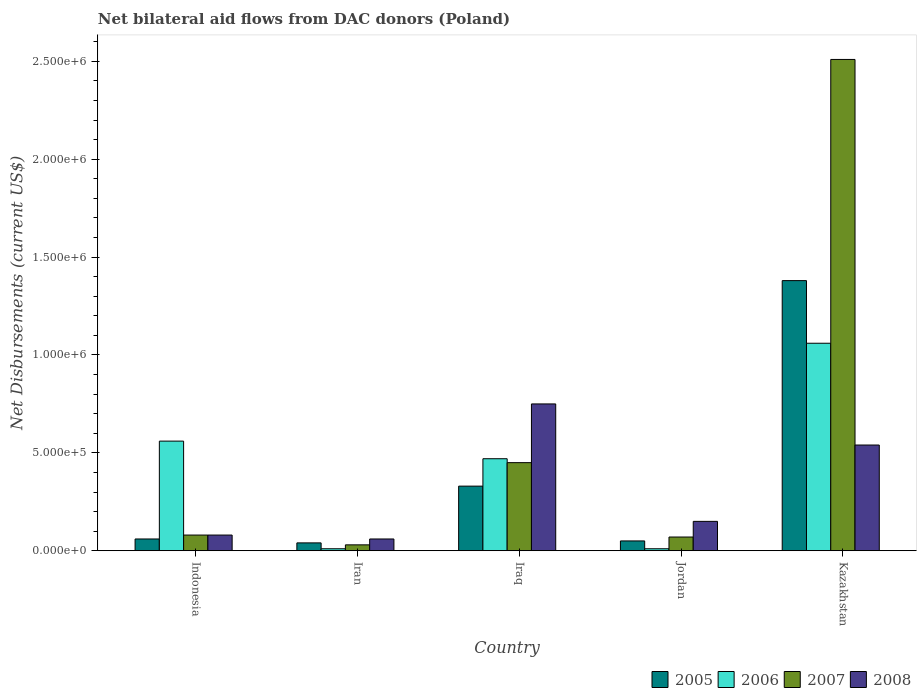Are the number of bars on each tick of the X-axis equal?
Your answer should be compact. Yes. What is the label of the 5th group of bars from the left?
Ensure brevity in your answer.  Kazakhstan. What is the net bilateral aid flows in 2008 in Iraq?
Keep it short and to the point. 7.50e+05. Across all countries, what is the maximum net bilateral aid flows in 2008?
Your answer should be very brief. 7.50e+05. In which country was the net bilateral aid flows in 2006 maximum?
Provide a short and direct response. Kazakhstan. In which country was the net bilateral aid flows in 2007 minimum?
Offer a terse response. Iran. What is the total net bilateral aid flows in 2006 in the graph?
Offer a terse response. 2.11e+06. What is the difference between the net bilateral aid flows in 2008 in Jordan and that in Kazakhstan?
Give a very brief answer. -3.90e+05. What is the difference between the net bilateral aid flows in 2007 in Kazakhstan and the net bilateral aid flows in 2006 in Jordan?
Make the answer very short. 2.50e+06. What is the average net bilateral aid flows in 2006 per country?
Make the answer very short. 4.22e+05. What is the difference between the net bilateral aid flows of/in 2006 and net bilateral aid flows of/in 2008 in Iran?
Offer a very short reply. -5.00e+04. In how many countries, is the net bilateral aid flows in 2008 greater than 200000 US$?
Provide a short and direct response. 2. What is the ratio of the net bilateral aid flows in 2006 in Iraq to that in Kazakhstan?
Your answer should be compact. 0.44. What is the difference between the highest and the second highest net bilateral aid flows in 2007?
Your answer should be very brief. 2.43e+06. What is the difference between the highest and the lowest net bilateral aid flows in 2006?
Provide a succinct answer. 1.05e+06. In how many countries, is the net bilateral aid flows in 2005 greater than the average net bilateral aid flows in 2005 taken over all countries?
Your answer should be compact. 1. Is the sum of the net bilateral aid flows in 2007 in Iraq and Kazakhstan greater than the maximum net bilateral aid flows in 2008 across all countries?
Provide a succinct answer. Yes. Is it the case that in every country, the sum of the net bilateral aid flows in 2005 and net bilateral aid flows in 2007 is greater than the sum of net bilateral aid flows in 2008 and net bilateral aid flows in 2006?
Offer a terse response. No. What does the 1st bar from the left in Jordan represents?
Offer a terse response. 2005. Is it the case that in every country, the sum of the net bilateral aid flows in 2007 and net bilateral aid flows in 2005 is greater than the net bilateral aid flows in 2006?
Make the answer very short. No. How many bars are there?
Offer a terse response. 20. How many legend labels are there?
Your answer should be compact. 4. How are the legend labels stacked?
Make the answer very short. Horizontal. What is the title of the graph?
Offer a terse response. Net bilateral aid flows from DAC donors (Poland). Does "1990" appear as one of the legend labels in the graph?
Your answer should be very brief. No. What is the label or title of the X-axis?
Give a very brief answer. Country. What is the label or title of the Y-axis?
Give a very brief answer. Net Disbursements (current US$). What is the Net Disbursements (current US$) in 2006 in Indonesia?
Offer a terse response. 5.60e+05. What is the Net Disbursements (current US$) of 2006 in Iran?
Give a very brief answer. 10000. What is the Net Disbursements (current US$) in 2005 in Iraq?
Ensure brevity in your answer.  3.30e+05. What is the Net Disbursements (current US$) of 2006 in Iraq?
Provide a succinct answer. 4.70e+05. What is the Net Disbursements (current US$) of 2008 in Iraq?
Make the answer very short. 7.50e+05. What is the Net Disbursements (current US$) in 2005 in Jordan?
Provide a short and direct response. 5.00e+04. What is the Net Disbursements (current US$) of 2008 in Jordan?
Make the answer very short. 1.50e+05. What is the Net Disbursements (current US$) in 2005 in Kazakhstan?
Your answer should be compact. 1.38e+06. What is the Net Disbursements (current US$) of 2006 in Kazakhstan?
Ensure brevity in your answer.  1.06e+06. What is the Net Disbursements (current US$) of 2007 in Kazakhstan?
Give a very brief answer. 2.51e+06. What is the Net Disbursements (current US$) in 2008 in Kazakhstan?
Make the answer very short. 5.40e+05. Across all countries, what is the maximum Net Disbursements (current US$) of 2005?
Ensure brevity in your answer.  1.38e+06. Across all countries, what is the maximum Net Disbursements (current US$) in 2006?
Make the answer very short. 1.06e+06. Across all countries, what is the maximum Net Disbursements (current US$) of 2007?
Your answer should be very brief. 2.51e+06. Across all countries, what is the maximum Net Disbursements (current US$) of 2008?
Give a very brief answer. 7.50e+05. Across all countries, what is the minimum Net Disbursements (current US$) in 2007?
Provide a succinct answer. 3.00e+04. What is the total Net Disbursements (current US$) of 2005 in the graph?
Your response must be concise. 1.86e+06. What is the total Net Disbursements (current US$) in 2006 in the graph?
Ensure brevity in your answer.  2.11e+06. What is the total Net Disbursements (current US$) in 2007 in the graph?
Ensure brevity in your answer.  3.14e+06. What is the total Net Disbursements (current US$) of 2008 in the graph?
Provide a succinct answer. 1.58e+06. What is the difference between the Net Disbursements (current US$) in 2007 in Indonesia and that in Iran?
Offer a very short reply. 5.00e+04. What is the difference between the Net Disbursements (current US$) of 2008 in Indonesia and that in Iran?
Make the answer very short. 2.00e+04. What is the difference between the Net Disbursements (current US$) in 2007 in Indonesia and that in Iraq?
Give a very brief answer. -3.70e+05. What is the difference between the Net Disbursements (current US$) in 2008 in Indonesia and that in Iraq?
Keep it short and to the point. -6.70e+05. What is the difference between the Net Disbursements (current US$) of 2005 in Indonesia and that in Jordan?
Make the answer very short. 10000. What is the difference between the Net Disbursements (current US$) in 2008 in Indonesia and that in Jordan?
Offer a very short reply. -7.00e+04. What is the difference between the Net Disbursements (current US$) of 2005 in Indonesia and that in Kazakhstan?
Your answer should be compact. -1.32e+06. What is the difference between the Net Disbursements (current US$) of 2006 in Indonesia and that in Kazakhstan?
Keep it short and to the point. -5.00e+05. What is the difference between the Net Disbursements (current US$) in 2007 in Indonesia and that in Kazakhstan?
Give a very brief answer. -2.43e+06. What is the difference between the Net Disbursements (current US$) of 2008 in Indonesia and that in Kazakhstan?
Offer a very short reply. -4.60e+05. What is the difference between the Net Disbursements (current US$) of 2006 in Iran and that in Iraq?
Keep it short and to the point. -4.60e+05. What is the difference between the Net Disbursements (current US$) in 2007 in Iran and that in Iraq?
Your answer should be very brief. -4.20e+05. What is the difference between the Net Disbursements (current US$) in 2008 in Iran and that in Iraq?
Your answer should be compact. -6.90e+05. What is the difference between the Net Disbursements (current US$) in 2005 in Iran and that in Jordan?
Make the answer very short. -10000. What is the difference between the Net Disbursements (current US$) of 2005 in Iran and that in Kazakhstan?
Your response must be concise. -1.34e+06. What is the difference between the Net Disbursements (current US$) of 2006 in Iran and that in Kazakhstan?
Give a very brief answer. -1.05e+06. What is the difference between the Net Disbursements (current US$) in 2007 in Iran and that in Kazakhstan?
Provide a short and direct response. -2.48e+06. What is the difference between the Net Disbursements (current US$) in 2008 in Iran and that in Kazakhstan?
Give a very brief answer. -4.80e+05. What is the difference between the Net Disbursements (current US$) in 2005 in Iraq and that in Jordan?
Provide a succinct answer. 2.80e+05. What is the difference between the Net Disbursements (current US$) of 2008 in Iraq and that in Jordan?
Your answer should be very brief. 6.00e+05. What is the difference between the Net Disbursements (current US$) in 2005 in Iraq and that in Kazakhstan?
Offer a terse response. -1.05e+06. What is the difference between the Net Disbursements (current US$) of 2006 in Iraq and that in Kazakhstan?
Offer a terse response. -5.90e+05. What is the difference between the Net Disbursements (current US$) in 2007 in Iraq and that in Kazakhstan?
Your response must be concise. -2.06e+06. What is the difference between the Net Disbursements (current US$) of 2008 in Iraq and that in Kazakhstan?
Your answer should be very brief. 2.10e+05. What is the difference between the Net Disbursements (current US$) of 2005 in Jordan and that in Kazakhstan?
Offer a very short reply. -1.33e+06. What is the difference between the Net Disbursements (current US$) in 2006 in Jordan and that in Kazakhstan?
Keep it short and to the point. -1.05e+06. What is the difference between the Net Disbursements (current US$) of 2007 in Jordan and that in Kazakhstan?
Provide a short and direct response. -2.44e+06. What is the difference between the Net Disbursements (current US$) of 2008 in Jordan and that in Kazakhstan?
Your answer should be compact. -3.90e+05. What is the difference between the Net Disbursements (current US$) in 2005 in Indonesia and the Net Disbursements (current US$) in 2006 in Iran?
Your response must be concise. 5.00e+04. What is the difference between the Net Disbursements (current US$) in 2005 in Indonesia and the Net Disbursements (current US$) in 2008 in Iran?
Your response must be concise. 0. What is the difference between the Net Disbursements (current US$) of 2006 in Indonesia and the Net Disbursements (current US$) of 2007 in Iran?
Offer a very short reply. 5.30e+05. What is the difference between the Net Disbursements (current US$) of 2006 in Indonesia and the Net Disbursements (current US$) of 2008 in Iran?
Provide a succinct answer. 5.00e+05. What is the difference between the Net Disbursements (current US$) in 2005 in Indonesia and the Net Disbursements (current US$) in 2006 in Iraq?
Offer a very short reply. -4.10e+05. What is the difference between the Net Disbursements (current US$) in 2005 in Indonesia and the Net Disbursements (current US$) in 2007 in Iraq?
Provide a succinct answer. -3.90e+05. What is the difference between the Net Disbursements (current US$) of 2005 in Indonesia and the Net Disbursements (current US$) of 2008 in Iraq?
Offer a very short reply. -6.90e+05. What is the difference between the Net Disbursements (current US$) in 2007 in Indonesia and the Net Disbursements (current US$) in 2008 in Iraq?
Give a very brief answer. -6.70e+05. What is the difference between the Net Disbursements (current US$) in 2005 in Indonesia and the Net Disbursements (current US$) in 2007 in Jordan?
Provide a short and direct response. -10000. What is the difference between the Net Disbursements (current US$) in 2006 in Indonesia and the Net Disbursements (current US$) in 2008 in Jordan?
Offer a terse response. 4.10e+05. What is the difference between the Net Disbursements (current US$) of 2005 in Indonesia and the Net Disbursements (current US$) of 2006 in Kazakhstan?
Your response must be concise. -1.00e+06. What is the difference between the Net Disbursements (current US$) in 2005 in Indonesia and the Net Disbursements (current US$) in 2007 in Kazakhstan?
Your response must be concise. -2.45e+06. What is the difference between the Net Disbursements (current US$) in 2005 in Indonesia and the Net Disbursements (current US$) in 2008 in Kazakhstan?
Keep it short and to the point. -4.80e+05. What is the difference between the Net Disbursements (current US$) of 2006 in Indonesia and the Net Disbursements (current US$) of 2007 in Kazakhstan?
Offer a very short reply. -1.95e+06. What is the difference between the Net Disbursements (current US$) of 2007 in Indonesia and the Net Disbursements (current US$) of 2008 in Kazakhstan?
Provide a short and direct response. -4.60e+05. What is the difference between the Net Disbursements (current US$) of 2005 in Iran and the Net Disbursements (current US$) of 2006 in Iraq?
Keep it short and to the point. -4.30e+05. What is the difference between the Net Disbursements (current US$) of 2005 in Iran and the Net Disbursements (current US$) of 2007 in Iraq?
Give a very brief answer. -4.10e+05. What is the difference between the Net Disbursements (current US$) of 2005 in Iran and the Net Disbursements (current US$) of 2008 in Iraq?
Ensure brevity in your answer.  -7.10e+05. What is the difference between the Net Disbursements (current US$) in 2006 in Iran and the Net Disbursements (current US$) in 2007 in Iraq?
Your answer should be compact. -4.40e+05. What is the difference between the Net Disbursements (current US$) of 2006 in Iran and the Net Disbursements (current US$) of 2008 in Iraq?
Ensure brevity in your answer.  -7.40e+05. What is the difference between the Net Disbursements (current US$) of 2007 in Iran and the Net Disbursements (current US$) of 2008 in Iraq?
Your response must be concise. -7.20e+05. What is the difference between the Net Disbursements (current US$) of 2005 in Iran and the Net Disbursements (current US$) of 2006 in Jordan?
Provide a short and direct response. 3.00e+04. What is the difference between the Net Disbursements (current US$) in 2005 in Iran and the Net Disbursements (current US$) in 2007 in Jordan?
Provide a succinct answer. -3.00e+04. What is the difference between the Net Disbursements (current US$) of 2006 in Iran and the Net Disbursements (current US$) of 2008 in Jordan?
Your answer should be compact. -1.40e+05. What is the difference between the Net Disbursements (current US$) in 2005 in Iran and the Net Disbursements (current US$) in 2006 in Kazakhstan?
Keep it short and to the point. -1.02e+06. What is the difference between the Net Disbursements (current US$) in 2005 in Iran and the Net Disbursements (current US$) in 2007 in Kazakhstan?
Keep it short and to the point. -2.47e+06. What is the difference between the Net Disbursements (current US$) of 2005 in Iran and the Net Disbursements (current US$) of 2008 in Kazakhstan?
Offer a very short reply. -5.00e+05. What is the difference between the Net Disbursements (current US$) in 2006 in Iran and the Net Disbursements (current US$) in 2007 in Kazakhstan?
Provide a succinct answer. -2.50e+06. What is the difference between the Net Disbursements (current US$) of 2006 in Iran and the Net Disbursements (current US$) of 2008 in Kazakhstan?
Your response must be concise. -5.30e+05. What is the difference between the Net Disbursements (current US$) of 2007 in Iran and the Net Disbursements (current US$) of 2008 in Kazakhstan?
Your response must be concise. -5.10e+05. What is the difference between the Net Disbursements (current US$) of 2005 in Iraq and the Net Disbursements (current US$) of 2006 in Jordan?
Offer a very short reply. 3.20e+05. What is the difference between the Net Disbursements (current US$) of 2005 in Iraq and the Net Disbursements (current US$) of 2007 in Jordan?
Your answer should be compact. 2.60e+05. What is the difference between the Net Disbursements (current US$) in 2006 in Iraq and the Net Disbursements (current US$) in 2007 in Jordan?
Provide a short and direct response. 4.00e+05. What is the difference between the Net Disbursements (current US$) in 2006 in Iraq and the Net Disbursements (current US$) in 2008 in Jordan?
Ensure brevity in your answer.  3.20e+05. What is the difference between the Net Disbursements (current US$) of 2005 in Iraq and the Net Disbursements (current US$) of 2006 in Kazakhstan?
Your answer should be compact. -7.30e+05. What is the difference between the Net Disbursements (current US$) in 2005 in Iraq and the Net Disbursements (current US$) in 2007 in Kazakhstan?
Ensure brevity in your answer.  -2.18e+06. What is the difference between the Net Disbursements (current US$) in 2006 in Iraq and the Net Disbursements (current US$) in 2007 in Kazakhstan?
Offer a very short reply. -2.04e+06. What is the difference between the Net Disbursements (current US$) in 2007 in Iraq and the Net Disbursements (current US$) in 2008 in Kazakhstan?
Offer a terse response. -9.00e+04. What is the difference between the Net Disbursements (current US$) in 2005 in Jordan and the Net Disbursements (current US$) in 2006 in Kazakhstan?
Offer a terse response. -1.01e+06. What is the difference between the Net Disbursements (current US$) in 2005 in Jordan and the Net Disbursements (current US$) in 2007 in Kazakhstan?
Provide a short and direct response. -2.46e+06. What is the difference between the Net Disbursements (current US$) of 2005 in Jordan and the Net Disbursements (current US$) of 2008 in Kazakhstan?
Your answer should be very brief. -4.90e+05. What is the difference between the Net Disbursements (current US$) in 2006 in Jordan and the Net Disbursements (current US$) in 2007 in Kazakhstan?
Provide a short and direct response. -2.50e+06. What is the difference between the Net Disbursements (current US$) in 2006 in Jordan and the Net Disbursements (current US$) in 2008 in Kazakhstan?
Keep it short and to the point. -5.30e+05. What is the difference between the Net Disbursements (current US$) in 2007 in Jordan and the Net Disbursements (current US$) in 2008 in Kazakhstan?
Make the answer very short. -4.70e+05. What is the average Net Disbursements (current US$) in 2005 per country?
Provide a short and direct response. 3.72e+05. What is the average Net Disbursements (current US$) in 2006 per country?
Give a very brief answer. 4.22e+05. What is the average Net Disbursements (current US$) in 2007 per country?
Keep it short and to the point. 6.28e+05. What is the average Net Disbursements (current US$) in 2008 per country?
Ensure brevity in your answer.  3.16e+05. What is the difference between the Net Disbursements (current US$) in 2005 and Net Disbursements (current US$) in 2006 in Indonesia?
Your answer should be compact. -5.00e+05. What is the difference between the Net Disbursements (current US$) in 2006 and Net Disbursements (current US$) in 2007 in Indonesia?
Provide a short and direct response. 4.80e+05. What is the difference between the Net Disbursements (current US$) in 2006 and Net Disbursements (current US$) in 2008 in Indonesia?
Offer a terse response. 4.80e+05. What is the difference between the Net Disbursements (current US$) in 2005 and Net Disbursements (current US$) in 2006 in Iran?
Make the answer very short. 3.00e+04. What is the difference between the Net Disbursements (current US$) of 2005 and Net Disbursements (current US$) of 2008 in Iran?
Your answer should be very brief. -2.00e+04. What is the difference between the Net Disbursements (current US$) of 2006 and Net Disbursements (current US$) of 2007 in Iran?
Your response must be concise. -2.00e+04. What is the difference between the Net Disbursements (current US$) in 2006 and Net Disbursements (current US$) in 2008 in Iran?
Offer a very short reply. -5.00e+04. What is the difference between the Net Disbursements (current US$) of 2005 and Net Disbursements (current US$) of 2006 in Iraq?
Keep it short and to the point. -1.40e+05. What is the difference between the Net Disbursements (current US$) of 2005 and Net Disbursements (current US$) of 2008 in Iraq?
Provide a succinct answer. -4.20e+05. What is the difference between the Net Disbursements (current US$) in 2006 and Net Disbursements (current US$) in 2007 in Iraq?
Ensure brevity in your answer.  2.00e+04. What is the difference between the Net Disbursements (current US$) in 2006 and Net Disbursements (current US$) in 2008 in Iraq?
Your response must be concise. -2.80e+05. What is the difference between the Net Disbursements (current US$) in 2007 and Net Disbursements (current US$) in 2008 in Iraq?
Provide a succinct answer. -3.00e+05. What is the difference between the Net Disbursements (current US$) in 2005 and Net Disbursements (current US$) in 2006 in Jordan?
Provide a short and direct response. 4.00e+04. What is the difference between the Net Disbursements (current US$) of 2006 and Net Disbursements (current US$) of 2007 in Jordan?
Your answer should be very brief. -6.00e+04. What is the difference between the Net Disbursements (current US$) of 2005 and Net Disbursements (current US$) of 2007 in Kazakhstan?
Offer a terse response. -1.13e+06. What is the difference between the Net Disbursements (current US$) in 2005 and Net Disbursements (current US$) in 2008 in Kazakhstan?
Provide a short and direct response. 8.40e+05. What is the difference between the Net Disbursements (current US$) in 2006 and Net Disbursements (current US$) in 2007 in Kazakhstan?
Your response must be concise. -1.45e+06. What is the difference between the Net Disbursements (current US$) of 2006 and Net Disbursements (current US$) of 2008 in Kazakhstan?
Your answer should be compact. 5.20e+05. What is the difference between the Net Disbursements (current US$) in 2007 and Net Disbursements (current US$) in 2008 in Kazakhstan?
Make the answer very short. 1.97e+06. What is the ratio of the Net Disbursements (current US$) of 2007 in Indonesia to that in Iran?
Your answer should be compact. 2.67. What is the ratio of the Net Disbursements (current US$) of 2008 in Indonesia to that in Iran?
Make the answer very short. 1.33. What is the ratio of the Net Disbursements (current US$) of 2005 in Indonesia to that in Iraq?
Provide a short and direct response. 0.18. What is the ratio of the Net Disbursements (current US$) of 2006 in Indonesia to that in Iraq?
Keep it short and to the point. 1.19. What is the ratio of the Net Disbursements (current US$) in 2007 in Indonesia to that in Iraq?
Provide a short and direct response. 0.18. What is the ratio of the Net Disbursements (current US$) of 2008 in Indonesia to that in Iraq?
Your answer should be very brief. 0.11. What is the ratio of the Net Disbursements (current US$) of 2005 in Indonesia to that in Jordan?
Offer a terse response. 1.2. What is the ratio of the Net Disbursements (current US$) of 2006 in Indonesia to that in Jordan?
Keep it short and to the point. 56. What is the ratio of the Net Disbursements (current US$) in 2008 in Indonesia to that in Jordan?
Offer a terse response. 0.53. What is the ratio of the Net Disbursements (current US$) in 2005 in Indonesia to that in Kazakhstan?
Offer a terse response. 0.04. What is the ratio of the Net Disbursements (current US$) in 2006 in Indonesia to that in Kazakhstan?
Keep it short and to the point. 0.53. What is the ratio of the Net Disbursements (current US$) of 2007 in Indonesia to that in Kazakhstan?
Keep it short and to the point. 0.03. What is the ratio of the Net Disbursements (current US$) of 2008 in Indonesia to that in Kazakhstan?
Give a very brief answer. 0.15. What is the ratio of the Net Disbursements (current US$) in 2005 in Iran to that in Iraq?
Your response must be concise. 0.12. What is the ratio of the Net Disbursements (current US$) in 2006 in Iran to that in Iraq?
Your response must be concise. 0.02. What is the ratio of the Net Disbursements (current US$) of 2007 in Iran to that in Iraq?
Give a very brief answer. 0.07. What is the ratio of the Net Disbursements (current US$) in 2007 in Iran to that in Jordan?
Give a very brief answer. 0.43. What is the ratio of the Net Disbursements (current US$) of 2005 in Iran to that in Kazakhstan?
Your response must be concise. 0.03. What is the ratio of the Net Disbursements (current US$) in 2006 in Iran to that in Kazakhstan?
Offer a very short reply. 0.01. What is the ratio of the Net Disbursements (current US$) of 2007 in Iran to that in Kazakhstan?
Your answer should be very brief. 0.01. What is the ratio of the Net Disbursements (current US$) of 2008 in Iran to that in Kazakhstan?
Keep it short and to the point. 0.11. What is the ratio of the Net Disbursements (current US$) of 2007 in Iraq to that in Jordan?
Your response must be concise. 6.43. What is the ratio of the Net Disbursements (current US$) of 2005 in Iraq to that in Kazakhstan?
Your response must be concise. 0.24. What is the ratio of the Net Disbursements (current US$) in 2006 in Iraq to that in Kazakhstan?
Make the answer very short. 0.44. What is the ratio of the Net Disbursements (current US$) of 2007 in Iraq to that in Kazakhstan?
Make the answer very short. 0.18. What is the ratio of the Net Disbursements (current US$) of 2008 in Iraq to that in Kazakhstan?
Your answer should be very brief. 1.39. What is the ratio of the Net Disbursements (current US$) in 2005 in Jordan to that in Kazakhstan?
Provide a succinct answer. 0.04. What is the ratio of the Net Disbursements (current US$) of 2006 in Jordan to that in Kazakhstan?
Offer a very short reply. 0.01. What is the ratio of the Net Disbursements (current US$) of 2007 in Jordan to that in Kazakhstan?
Keep it short and to the point. 0.03. What is the ratio of the Net Disbursements (current US$) in 2008 in Jordan to that in Kazakhstan?
Ensure brevity in your answer.  0.28. What is the difference between the highest and the second highest Net Disbursements (current US$) in 2005?
Make the answer very short. 1.05e+06. What is the difference between the highest and the second highest Net Disbursements (current US$) of 2007?
Your response must be concise. 2.06e+06. What is the difference between the highest and the second highest Net Disbursements (current US$) in 2008?
Provide a short and direct response. 2.10e+05. What is the difference between the highest and the lowest Net Disbursements (current US$) of 2005?
Ensure brevity in your answer.  1.34e+06. What is the difference between the highest and the lowest Net Disbursements (current US$) of 2006?
Offer a very short reply. 1.05e+06. What is the difference between the highest and the lowest Net Disbursements (current US$) of 2007?
Your answer should be compact. 2.48e+06. What is the difference between the highest and the lowest Net Disbursements (current US$) of 2008?
Your answer should be very brief. 6.90e+05. 